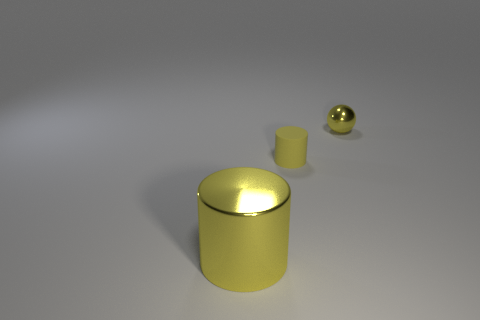There is a metallic object that is the same color as the small shiny ball; what size is it?
Your answer should be compact. Large. Is there another yellow metallic object of the same shape as the large object?
Your answer should be very brief. No. Do the metal object to the left of the small yellow metallic object and the yellow cylinder behind the large yellow shiny cylinder have the same size?
Offer a very short reply. No. Is the number of shiny things left of the yellow rubber thing less than the number of large metal cylinders to the right of the tiny ball?
Provide a short and direct response. No. There is a tiny thing that is the same color as the small cylinder; what material is it?
Provide a short and direct response. Metal. What is the color of the shiny object right of the yellow matte cylinder?
Provide a short and direct response. Yellow. Is the tiny shiny ball the same color as the matte cylinder?
Ensure brevity in your answer.  Yes. How many shiny objects are on the right side of the yellow metal object that is to the left of the tiny thing behind the yellow matte thing?
Provide a short and direct response. 1. How big is the matte thing?
Your answer should be very brief. Small. There is another object that is the same size as the yellow rubber object; what material is it?
Offer a very short reply. Metal. 